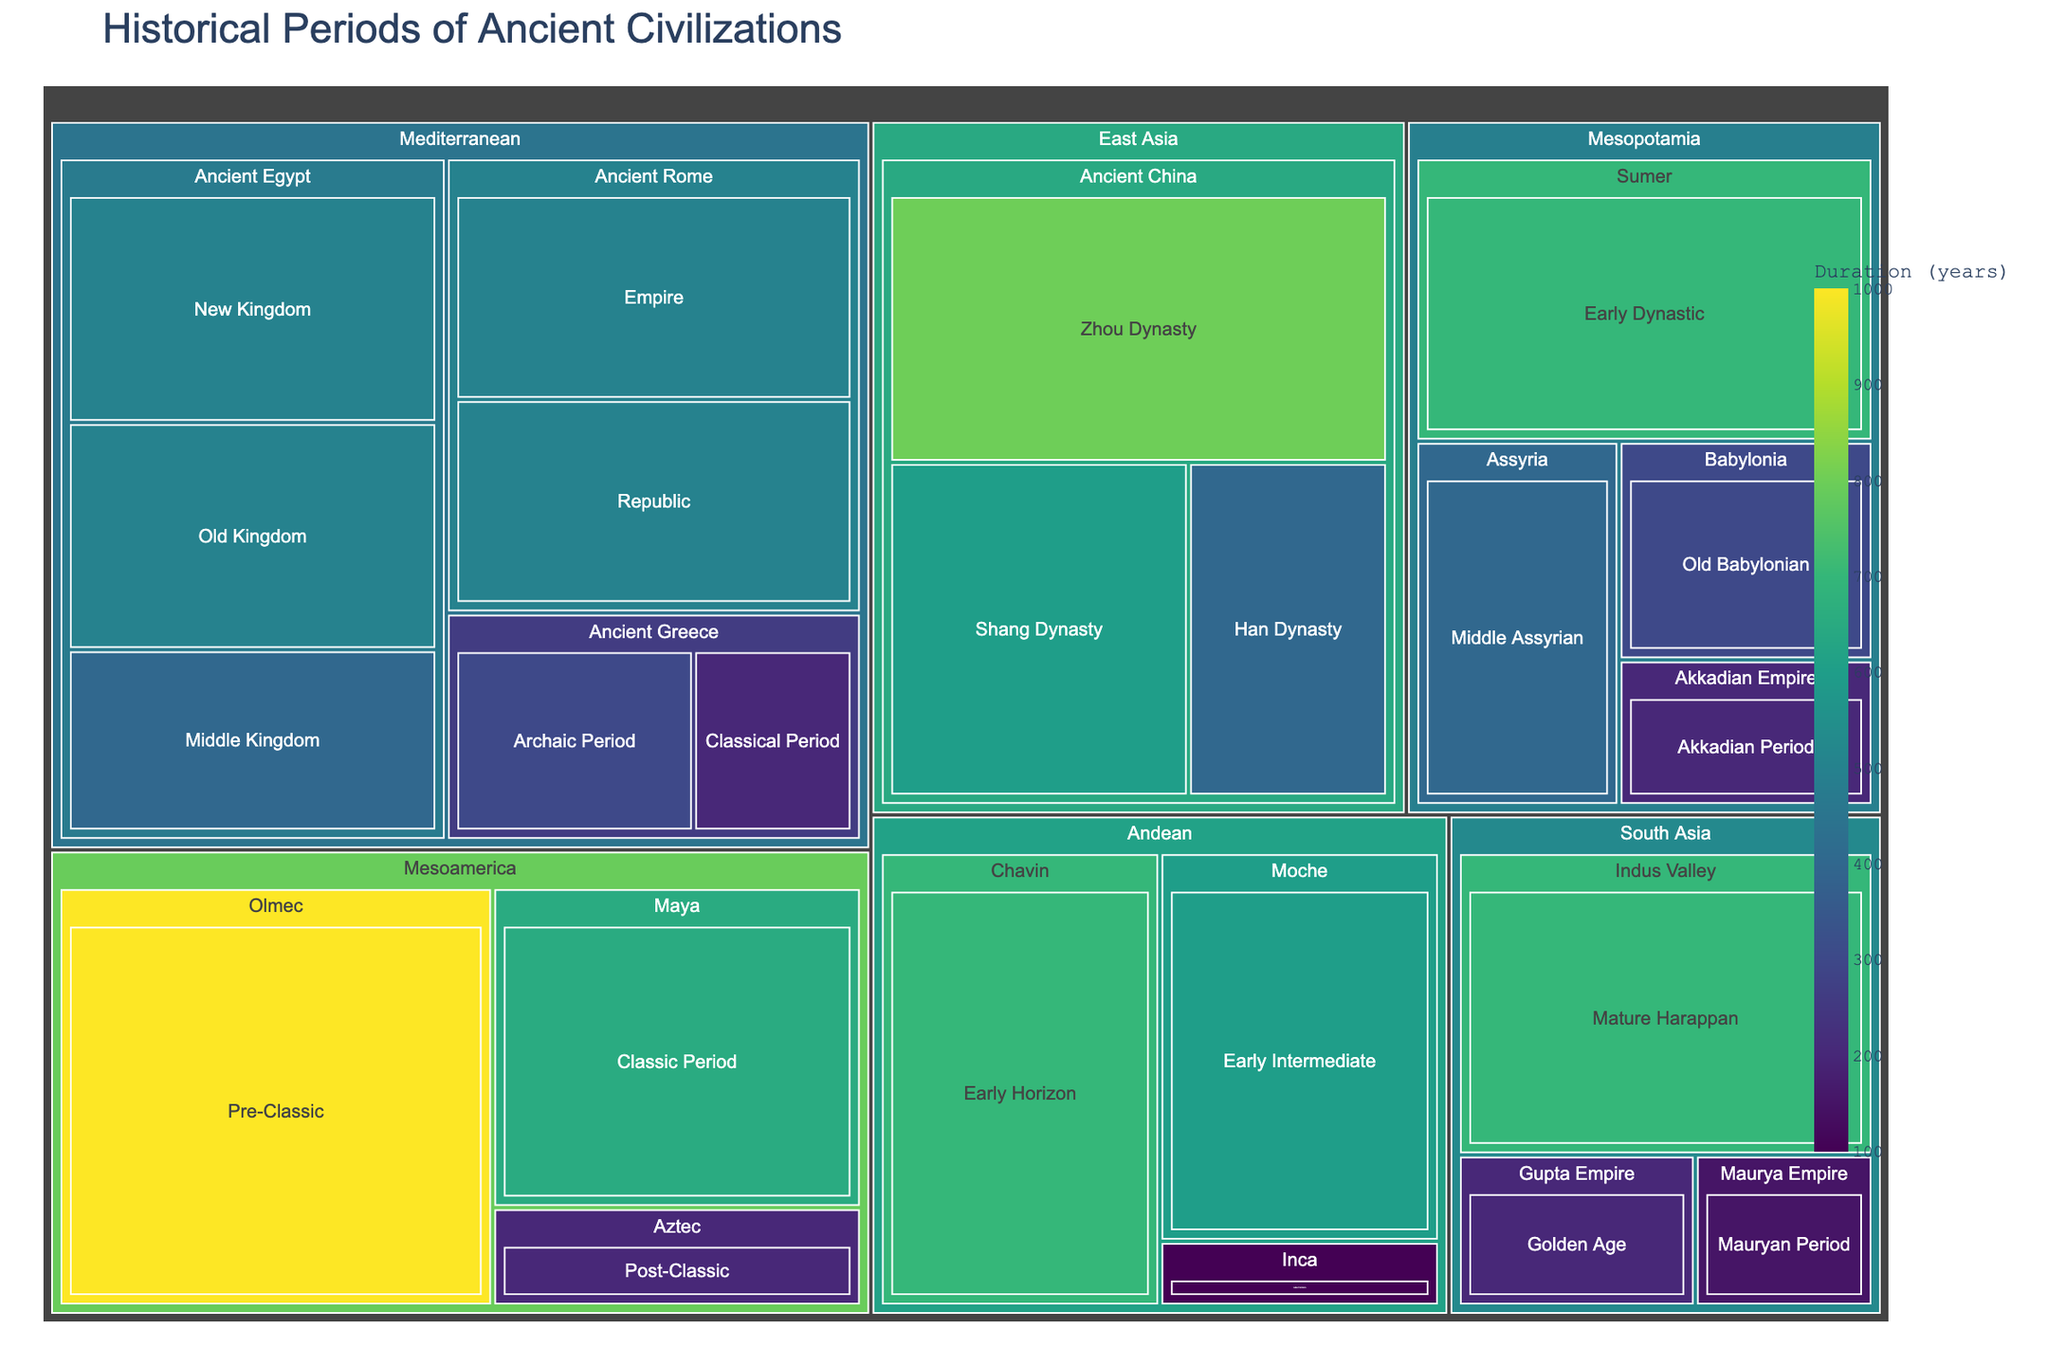What's the title of the treemap? The title is often positioned at the top of the figure and provides a summary of the content. In this case, the treemap's title is "Historical Periods of Ancient Civilizations".
Answer: Historical Periods of Ancient Civilizations Which region has the longest duration period in the figure? The longest duration period can be identified by looking at the largest section within the treemap. For this figure, the Pre-Classic period of the Olmec civilization in the Mesoamerica region spans 1000 years.
Answer: Mesoamerica How many civilizations are represented under the Mediterranean region? Each box within the Mediterranean region represents a different civilization. There are three distinct civilizations listed: Ancient Egypt, Ancient Greece, and Ancient Rome.
Answer: 3 Which civilization in Mesopotamia has the shortest historical period by duration? Within the Mesopotamia region, each civilization's period is represented by a box. The Akkadian Empire has the shortest duration at 200 years.
Answer: Akkadian Empire Compare the total duration of historical periods in East Asia and South Asia. Which one is longer? Sum the durations of all periods in East Asia and South Asia. East Asia: Shang Dynasty (600) + Zhou Dynasty (800) + Han Dynasty (400) = 1800 years. South Asia: Mature Harappan (700) + Mauryan Period (150) + Golden Age (200) = 1050 years. East Asia has a longer total duration.
Answer: East Asia Which periods in the Mediterranean region have the same duration? Look for periods within the Mediterranean region that have identical numerical values for their duration. Both the Old Kingdom of Ancient Egypt and the Empire of Ancient Rome last for 500 years.
Answer: Old Kingdom of Ancient Egypt and Empire of Ancient Rome What is the average duration of the historical periods listed under the Mesopotamia region? Sum the durations of all periods in Mesopotamia and divide by the number of periods. Total duration: 700 (Early Dynastic) + 200 (Akkadian Period) + 300 (Old Babylonian) + 400 (Middle Assyrian) = 1600 years. Number of periods: 4. Average = 1600/4 = 400 years.
Answer: 400 years How do the durations of civilizations in East Asia compare to those in the Andean region? Sum the durations of all periods in East Asia and Andean regions. East Asia: 600 (Shang Dynasty) + 800 (Zhou Dynasty) + 400 (Han Dynasty) = 1800 years. Andean: 700 (Early Horizon) + 600 (Early Intermediate) + 100 (Late Horizon) = 1400 years. East Asia has longer combined durations than Andean.
Answer: East Asia has longer durations 